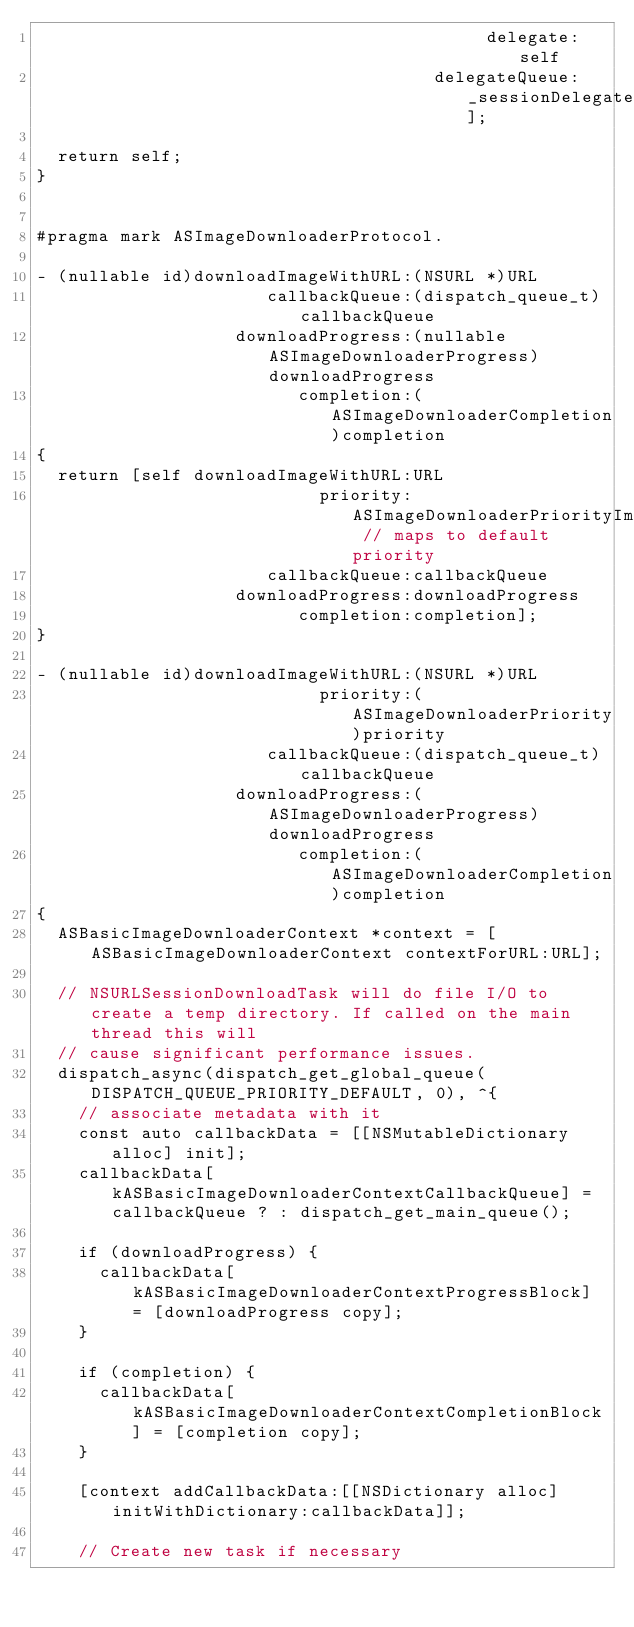Convert code to text. <code><loc_0><loc_0><loc_500><loc_500><_ObjectiveC_>                                           delegate:self
                                      delegateQueue:_sessionDelegateQueue];

  return self;
}


#pragma mark ASImageDownloaderProtocol.

- (nullable id)downloadImageWithURL:(NSURL *)URL
                      callbackQueue:(dispatch_queue_t)callbackQueue
                   downloadProgress:(nullable ASImageDownloaderProgress)downloadProgress
                         completion:(ASImageDownloaderCompletion)completion
{
  return [self downloadImageWithURL:URL
                           priority:ASImageDownloaderPriorityImminent // maps to default priority
                      callbackQueue:callbackQueue
                   downloadProgress:downloadProgress
                         completion:completion];
}

- (nullable id)downloadImageWithURL:(NSURL *)URL
                           priority:(ASImageDownloaderPriority)priority
                      callbackQueue:(dispatch_queue_t)callbackQueue
                   downloadProgress:(ASImageDownloaderProgress)downloadProgress
                         completion:(ASImageDownloaderCompletion)completion
{
  ASBasicImageDownloaderContext *context = [ASBasicImageDownloaderContext contextForURL:URL];

  // NSURLSessionDownloadTask will do file I/O to create a temp directory. If called on the main thread this will
  // cause significant performance issues.
  dispatch_async(dispatch_get_global_queue(DISPATCH_QUEUE_PRIORITY_DEFAULT, 0), ^{
    // associate metadata with it
    const auto callbackData = [[NSMutableDictionary alloc] init];
    callbackData[kASBasicImageDownloaderContextCallbackQueue] = callbackQueue ? : dispatch_get_main_queue();

    if (downloadProgress) {
      callbackData[kASBasicImageDownloaderContextProgressBlock] = [downloadProgress copy];
    }

    if (completion) {
      callbackData[kASBasicImageDownloaderContextCompletionBlock] = [completion copy];
    }

    [context addCallbackData:[[NSDictionary alloc] initWithDictionary:callbackData]];

    // Create new task if necessary</code> 